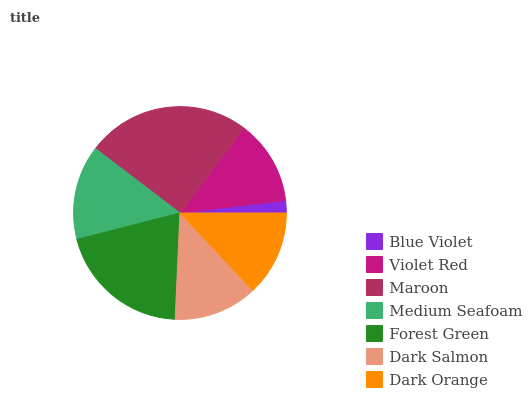Is Blue Violet the minimum?
Answer yes or no. Yes. Is Maroon the maximum?
Answer yes or no. Yes. Is Violet Red the minimum?
Answer yes or no. No. Is Violet Red the maximum?
Answer yes or no. No. Is Violet Red greater than Blue Violet?
Answer yes or no. Yes. Is Blue Violet less than Violet Red?
Answer yes or no. Yes. Is Blue Violet greater than Violet Red?
Answer yes or no. No. Is Violet Red less than Blue Violet?
Answer yes or no. No. Is Dark Orange the high median?
Answer yes or no. Yes. Is Dark Orange the low median?
Answer yes or no. Yes. Is Dark Salmon the high median?
Answer yes or no. No. Is Medium Seafoam the low median?
Answer yes or no. No. 